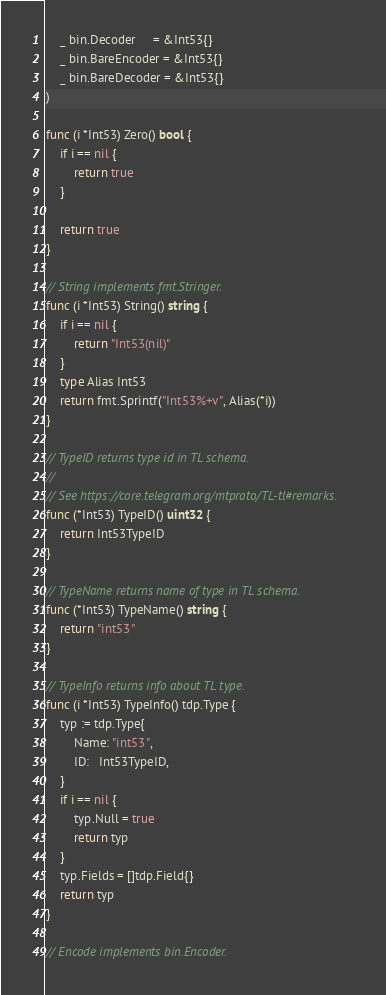Convert code to text. <code><loc_0><loc_0><loc_500><loc_500><_Go_>	_ bin.Decoder     = &Int53{}
	_ bin.BareEncoder = &Int53{}
	_ bin.BareDecoder = &Int53{}
)

func (i *Int53) Zero() bool {
	if i == nil {
		return true
	}

	return true
}

// String implements fmt.Stringer.
func (i *Int53) String() string {
	if i == nil {
		return "Int53(nil)"
	}
	type Alias Int53
	return fmt.Sprintf("Int53%+v", Alias(*i))
}

// TypeID returns type id in TL schema.
//
// See https://core.telegram.org/mtproto/TL-tl#remarks.
func (*Int53) TypeID() uint32 {
	return Int53TypeID
}

// TypeName returns name of type in TL schema.
func (*Int53) TypeName() string {
	return "int53"
}

// TypeInfo returns info about TL type.
func (i *Int53) TypeInfo() tdp.Type {
	typ := tdp.Type{
		Name: "int53",
		ID:   Int53TypeID,
	}
	if i == nil {
		typ.Null = true
		return typ
	}
	typ.Fields = []tdp.Field{}
	return typ
}

// Encode implements bin.Encoder.</code> 